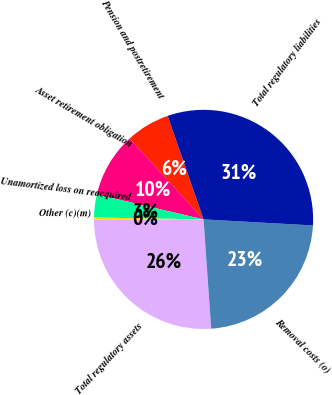Convert chart. <chart><loc_0><loc_0><loc_500><loc_500><pie_chart><fcel>Pension and postretirement<fcel>Asset retirement obligation<fcel>Unamortized loss on reacquired<fcel>Other (c)(m)<fcel>Total regulatory assets<fcel>Removal costs (o)<fcel>Total regulatory liabilities<nl><fcel>6.47%<fcel>9.56%<fcel>3.38%<fcel>0.29%<fcel>26.1%<fcel>23.01%<fcel>31.19%<nl></chart> 